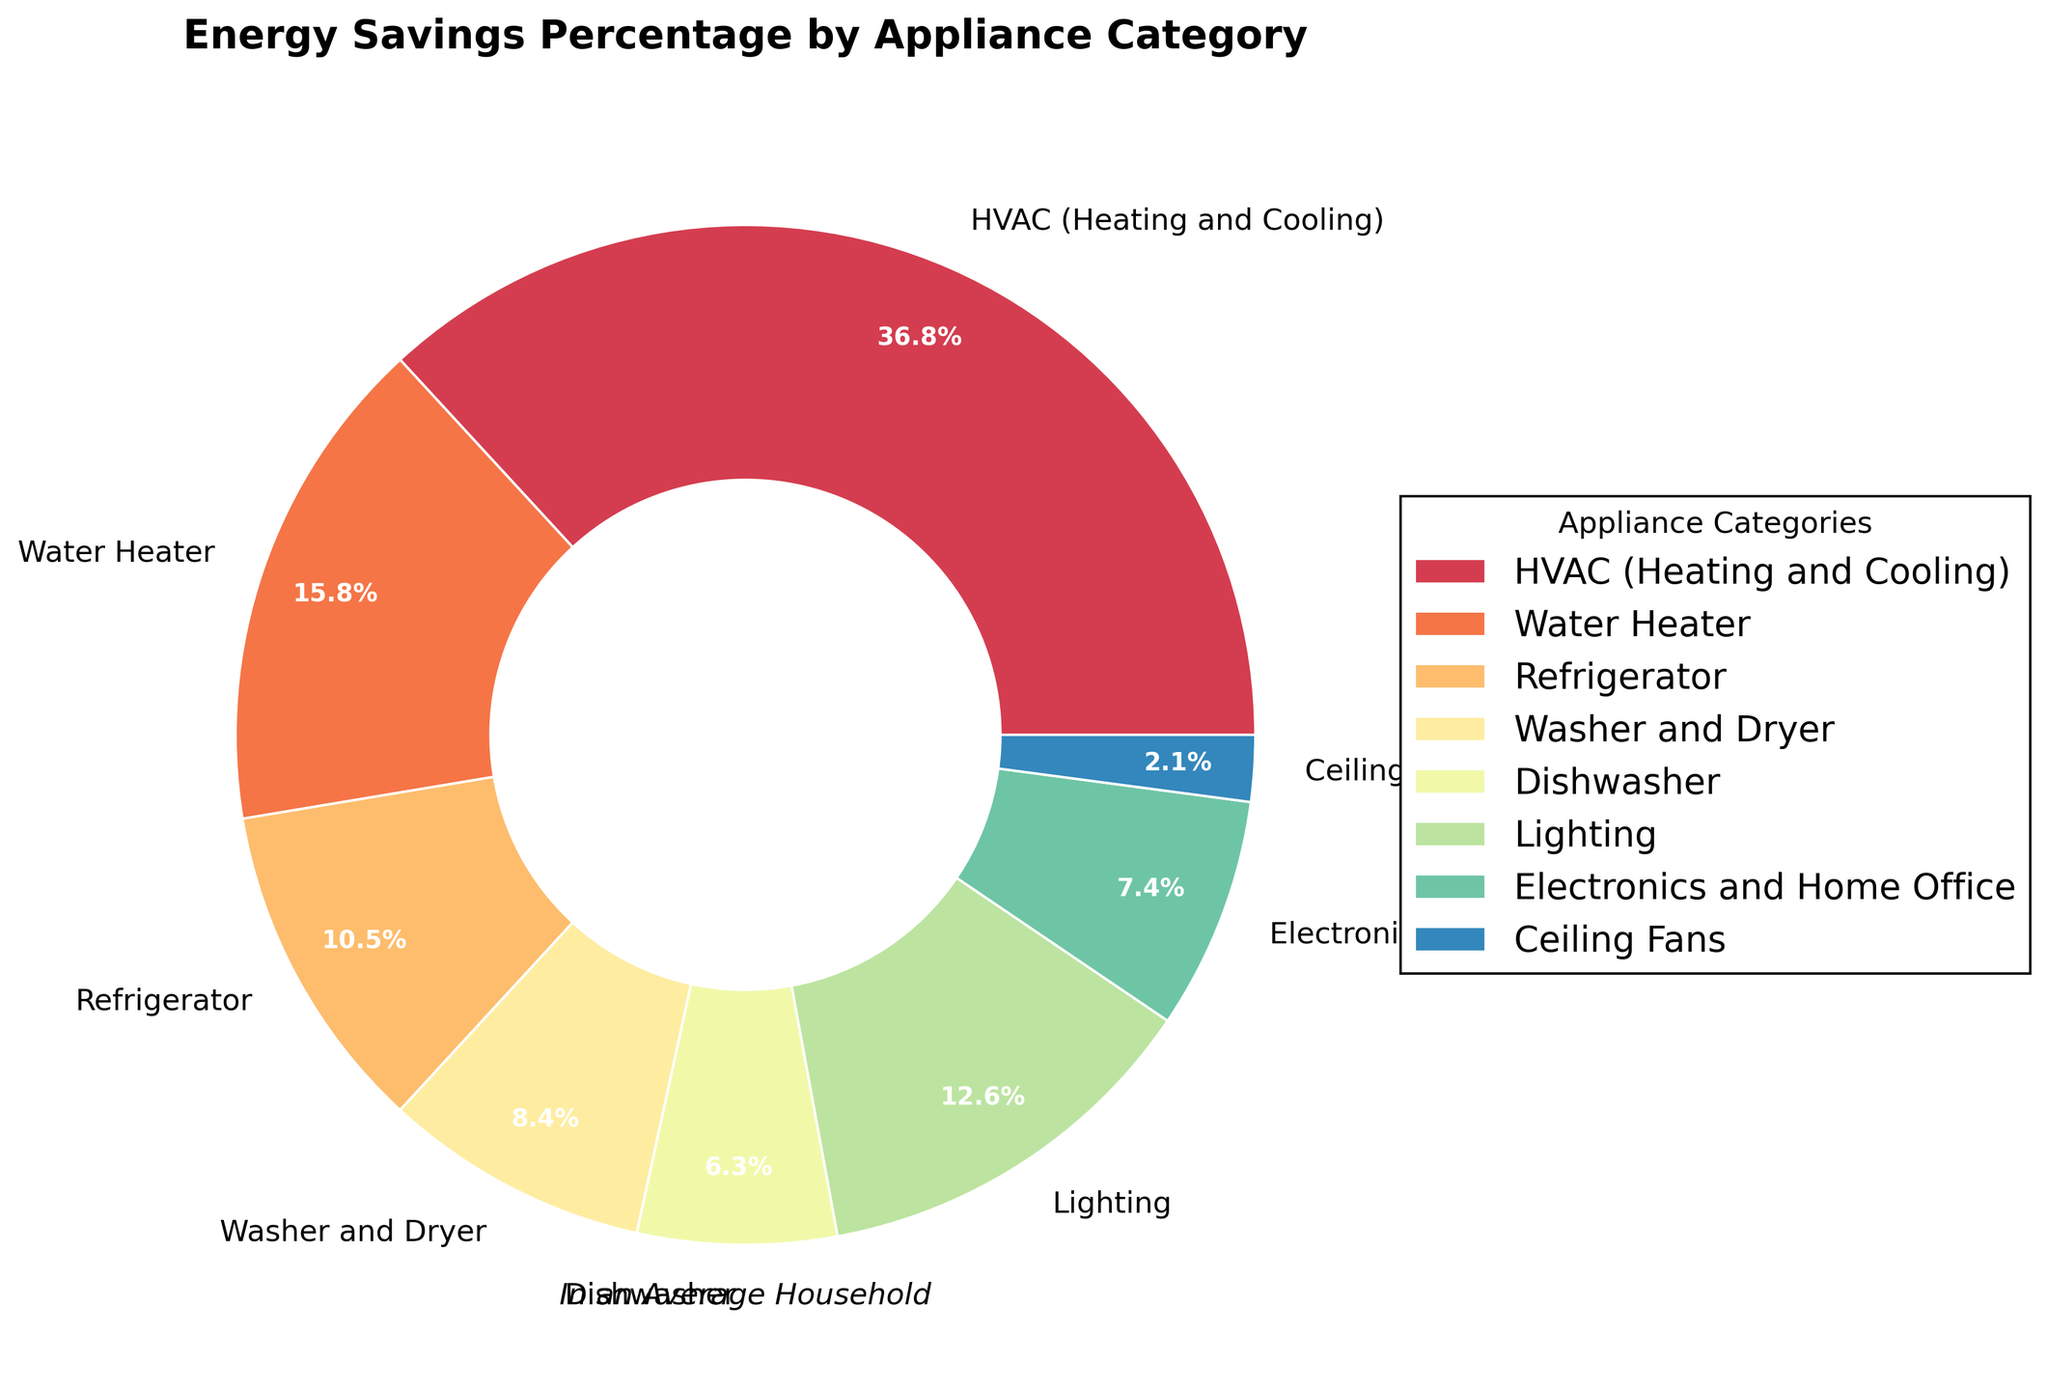What appliance category has the highest energy savings percentage? By looking at the pie chart, the segment that occupies the largest area corresponds to the HVAC (Heating and Cooling) category, which has the highest percentage.
Answer: HVAC (Heating and Cooling) What is the combined energy savings percentage for Washer and Dryer and Dishwasher? To find the combined percentage, sum up the energy savings percentages of Washer and Dryer (8%) and Dishwasher (6%). The calculation is 8% + 6% = 14%.
Answer: 14% Which category saves more energy: Lighting or Water Heater? By comparing the two categories on the pie chart, Lighting has a percentage of 12%, and Water Heater has a percentage of 15%. Since 15% is greater than 12%, Water Heater saves more energy.
Answer: Water Heater What is the difference in energy savings percentage between the Refrigerator and Ceiling Fans? Subtract the energy savings percentage of Ceiling Fans (2%) from that of the Refrigerator (10%). The calculation is 10% - 2% = 8%.
Answer: 8% How many categories have energy savings percentages greater than 10%? By examining the pie chart, categories with percentages greater than 10% are HVAC (35%), Water Heater (15%), and Lighting (12%). In total, there are three categories.
Answer: 3 Which appliance category has the smallest energy savings percentage? By observing the pie chart, the smallest segment corresponds to Ceiling Fans, with an energy savings percentage of 2%.
Answer: Ceiling Fans Is the energy savings percentage for Electronics and Home Office greater than or equal to the sum of Washer and Dryer and Ceiling Fans? To determine this, compare the percentage for Electronics and Home Office (7%) with the sum of Washer and Dryer (8%) and Ceiling Fans (2%). The sum is 8% + 2% = 10%, which is greater than 7%. So, the statement is false.
Answer: No What are the energy savings percentages for categories that fall between the Refrigerator and Lighting? By checking the values on the pie chart, the percentages that lie between the Refrigerator (10%) and Lighting (12%) are those of Washer and Dryer (8%), Dishwasher (6%), and Electronics and Home Office (7%).
Answer: 8%, 6%, and 7% If we exclude HVAC and Water Heater, what fraction of the total energy savings percentages is contributed by the remaining categories? First, sum the percentages of the remaining categories: Refrigerator (10%), Washer and Dryer (8%), Dishwasher (6%), Lighting (12%), Electronics and Home Office (7%), and Ceiling Fans (2%). The sum is 10% + 8% + 6% + 12% + 7% + 2% = 45%. The HVAC and Water Heater together contribute 35% + 15% = 50%, so the fraction is 45/100 or 45%.
Answer: 45% What fraction of the total energy savings is contributed by appliances for which the percentage is less than 10%? Identify and sum the percentages of these categories: Washer and Dryer (8%), Dishwasher (6%), Electronics and Home Office (7%), and Ceiling Fans (2%). Their total is 8% + 6% + 7% + 2% = 23%, which is the fraction of the total energy savings.
Answer: 23% 